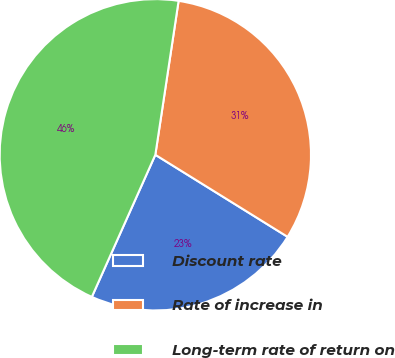Convert chart. <chart><loc_0><loc_0><loc_500><loc_500><pie_chart><fcel>Discount rate<fcel>Rate of increase in<fcel>Long-term rate of return on<nl><fcel>22.85%<fcel>31.45%<fcel>45.7%<nl></chart> 